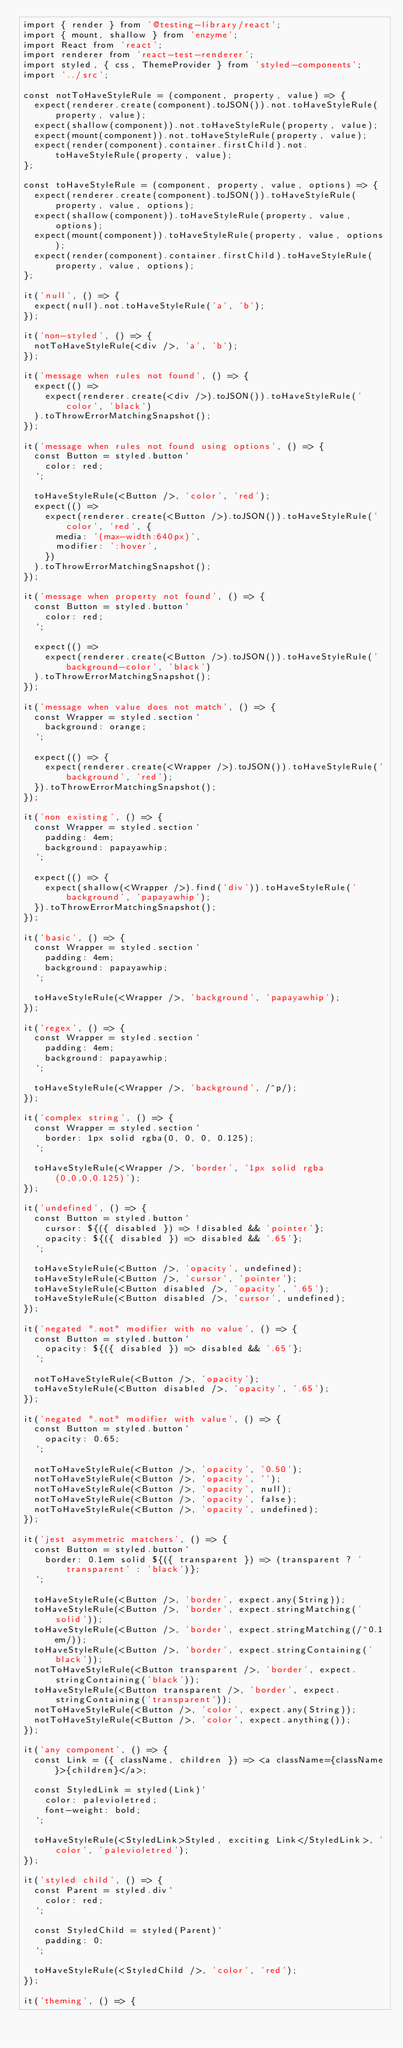Convert code to text. <code><loc_0><loc_0><loc_500><loc_500><_JavaScript_>import { render } from '@testing-library/react';
import { mount, shallow } from 'enzyme';
import React from 'react';
import renderer from 'react-test-renderer';
import styled, { css, ThemeProvider } from 'styled-components';
import '../src';

const notToHaveStyleRule = (component, property, value) => {
  expect(renderer.create(component).toJSON()).not.toHaveStyleRule(property, value);
  expect(shallow(component)).not.toHaveStyleRule(property, value);
  expect(mount(component)).not.toHaveStyleRule(property, value);
  expect(render(component).container.firstChild).not.toHaveStyleRule(property, value);
};

const toHaveStyleRule = (component, property, value, options) => {
  expect(renderer.create(component).toJSON()).toHaveStyleRule(property, value, options);
  expect(shallow(component)).toHaveStyleRule(property, value, options);
  expect(mount(component)).toHaveStyleRule(property, value, options);
  expect(render(component).container.firstChild).toHaveStyleRule(property, value, options);
};

it('null', () => {
  expect(null).not.toHaveStyleRule('a', 'b');
});

it('non-styled', () => {
  notToHaveStyleRule(<div />, 'a', 'b');
});

it('message when rules not found', () => {
  expect(() =>
    expect(renderer.create(<div />).toJSON()).toHaveStyleRule('color', 'black')
  ).toThrowErrorMatchingSnapshot();
});

it('message when rules not found using options', () => {
  const Button = styled.button`
    color: red;
  `;

  toHaveStyleRule(<Button />, 'color', 'red');
  expect(() =>
    expect(renderer.create(<Button />).toJSON()).toHaveStyleRule('color', 'red', {
      media: '(max-width:640px)',
      modifier: ':hover',
    })
  ).toThrowErrorMatchingSnapshot();
});

it('message when property not found', () => {
  const Button = styled.button`
    color: red;
  `;

  expect(() =>
    expect(renderer.create(<Button />).toJSON()).toHaveStyleRule('background-color', 'black')
  ).toThrowErrorMatchingSnapshot();
});

it('message when value does not match', () => {
  const Wrapper = styled.section`
    background: orange;
  `;

  expect(() => {
    expect(renderer.create(<Wrapper />).toJSON()).toHaveStyleRule('background', 'red');
  }).toThrowErrorMatchingSnapshot();
});

it('non existing', () => {
  const Wrapper = styled.section`
    padding: 4em;
    background: papayawhip;
  `;

  expect(() => {
    expect(shallow(<Wrapper />).find('div')).toHaveStyleRule('background', 'papayawhip');
  }).toThrowErrorMatchingSnapshot();
});

it('basic', () => {
  const Wrapper = styled.section`
    padding: 4em;
    background: papayawhip;
  `;

  toHaveStyleRule(<Wrapper />, 'background', 'papayawhip');
});

it('regex', () => {
  const Wrapper = styled.section`
    padding: 4em;
    background: papayawhip;
  `;

  toHaveStyleRule(<Wrapper />, 'background', /^p/);
});

it('complex string', () => {
  const Wrapper = styled.section`
    border: 1px solid rgba(0, 0, 0, 0.125);
  `;

  toHaveStyleRule(<Wrapper />, 'border', '1px solid rgba(0,0,0,0.125)');
});

it('undefined', () => {
  const Button = styled.button`
    cursor: ${({ disabled }) => !disabled && 'pointer'};
    opacity: ${({ disabled }) => disabled && '.65'};
  `;

  toHaveStyleRule(<Button />, 'opacity', undefined);
  toHaveStyleRule(<Button />, 'cursor', 'pointer');
  toHaveStyleRule(<Button disabled />, 'opacity', '.65');
  toHaveStyleRule(<Button disabled />, 'cursor', undefined);
});

it('negated ".not" modifier with no value', () => {
  const Button = styled.button`
    opacity: ${({ disabled }) => disabled && '.65'};
  `;

  notToHaveStyleRule(<Button />, 'opacity');
  toHaveStyleRule(<Button disabled />, 'opacity', '.65');
});

it('negated ".not" modifier with value', () => {
  const Button = styled.button`
    opacity: 0.65;
  `;

  notToHaveStyleRule(<Button />, 'opacity', '0.50');
  notToHaveStyleRule(<Button />, 'opacity', '');
  notToHaveStyleRule(<Button />, 'opacity', null);
  notToHaveStyleRule(<Button />, 'opacity', false);
  notToHaveStyleRule(<Button />, 'opacity', undefined);
});

it('jest asymmetric matchers', () => {
  const Button = styled.button`
    border: 0.1em solid ${({ transparent }) => (transparent ? 'transparent' : 'black')};
  `;

  toHaveStyleRule(<Button />, 'border', expect.any(String));
  toHaveStyleRule(<Button />, 'border', expect.stringMatching('solid'));
  toHaveStyleRule(<Button />, 'border', expect.stringMatching(/^0.1em/));
  toHaveStyleRule(<Button />, 'border', expect.stringContaining('black'));
  notToHaveStyleRule(<Button transparent />, 'border', expect.stringContaining('black'));
  toHaveStyleRule(<Button transparent />, 'border', expect.stringContaining('transparent'));
  notToHaveStyleRule(<Button />, 'color', expect.any(String));
  notToHaveStyleRule(<Button />, 'color', expect.anything());
});

it('any component', () => {
  const Link = ({ className, children }) => <a className={className}>{children}</a>;

  const StyledLink = styled(Link)`
    color: palevioletred;
    font-weight: bold;
  `;

  toHaveStyleRule(<StyledLink>Styled, exciting Link</StyledLink>, 'color', 'palevioletred');
});

it('styled child', () => {
  const Parent = styled.div`
    color: red;
  `;

  const StyledChild = styled(Parent)`
    padding: 0;
  `;

  toHaveStyleRule(<StyledChild />, 'color', 'red');
});

it('theming', () => {</code> 